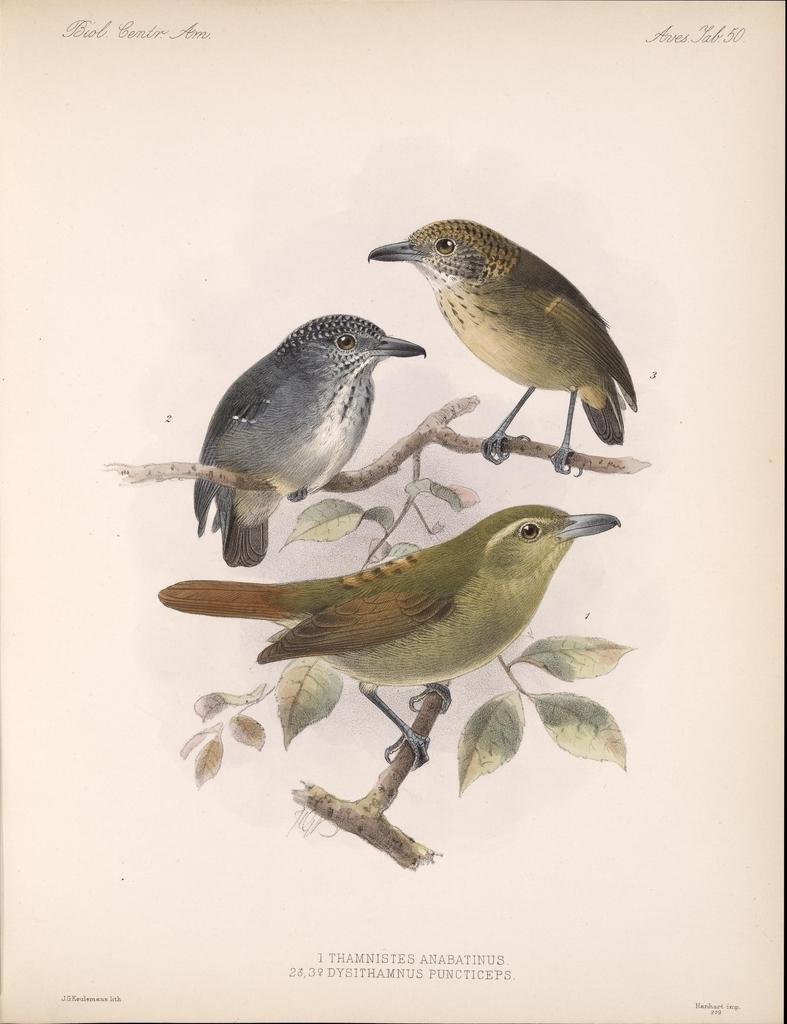How would you summarize this image in a sentence or two? In this image we can see a paper. On this paper we can see pictures of birds, branches, and leaves. At the top and bottom of the image we can see something is written on it. 